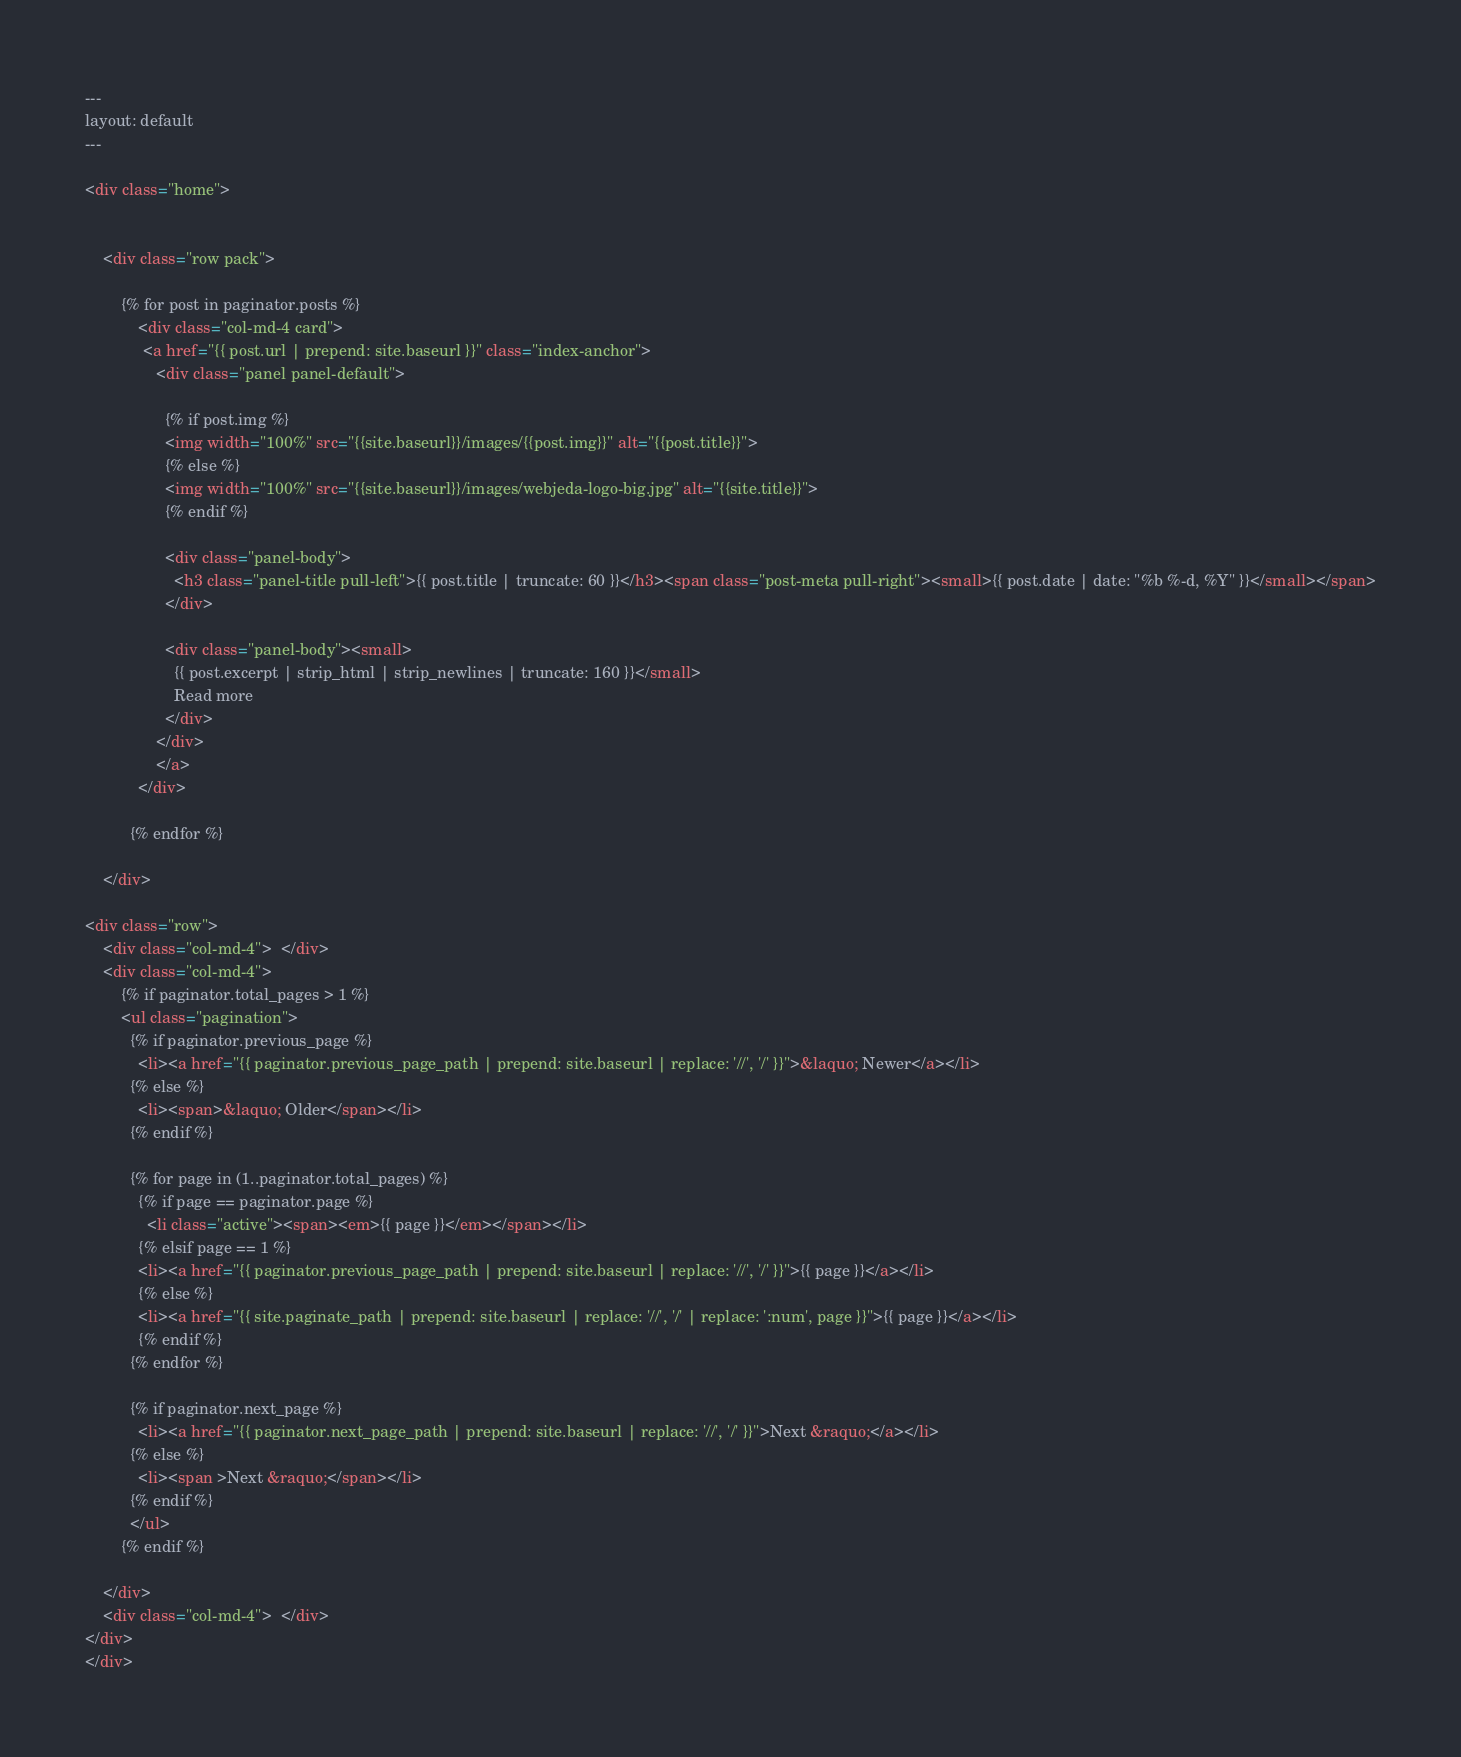Convert code to text. <code><loc_0><loc_0><loc_500><loc_500><_HTML_>---
layout: default
---

<div class="home">
 
  
    <div class="row pack">

        {% for post in paginator.posts %}   
            <div class="col-md-4 card">
             <a href="{{ post.url | prepend: site.baseurl }}" class="index-anchor">    
                <div class="panel panel-default">
                  
                  {% if post.img %}
                  <img width="100%" src="{{site.baseurl}}/images/{{post.img}}" alt="{{post.title}}">
                  {% else %}
                  <img width="100%" src="{{site.baseurl}}/images/webjeda-logo-big.jpg" alt="{{site.title}}">
                  {% endif %}
                  
                  <div class="panel-body">
                    <h3 class="panel-title pull-left">{{ post.title | truncate: 60 }}</h3><span class="post-meta pull-right"><small>{{ post.date | date: "%b %-d, %Y" }}</small></span>
                  </div>
                  
                  <div class="panel-body"><small>
                    {{ post.excerpt | strip_html | strip_newlines | truncate: 160 }}</small>
                    Read more
                  </div>
                </div>
                </a>
            </div>
        
          {% endfor %}

    </div> 
    
<div class="row">
    <div class="col-md-4">  </div>
    <div class="col-md-4">
        {% if paginator.total_pages > 1 %}
        <ul class="pagination">
          {% if paginator.previous_page %}
            <li><a href="{{ paginator.previous_page_path | prepend: site.baseurl | replace: '//', '/' }}">&laquo; Newer</a></li>
          {% else %}
            <li><span>&laquo; Older</span></li>
          {% endif %}

          {% for page in (1..paginator.total_pages) %}
            {% if page == paginator.page %}
              <li class="active"><span><em>{{ page }}</em></span></li>
            {% elsif page == 1 %}
            <li><a href="{{ paginator.previous_page_path | prepend: site.baseurl | replace: '//', '/' }}">{{ page }}</a></li>
            {% else %}
            <li><a href="{{ site.paginate_path | prepend: site.baseurl | replace: '//', '/' | replace: ':num', page }}">{{ page }}</a></li>
            {% endif %}
          {% endfor %}

          {% if paginator.next_page %}
            <li><a href="{{ paginator.next_page_path | prepend: site.baseurl | replace: '//', '/' }}">Next &raquo;</a></li>
          {% else %}
            <li><span >Next &raquo;</span></li>
          {% endif %}
          </ul>
        {% endif %}

    </div>
    <div class="col-md-4">  </div>
</div>
</div>
</code> 